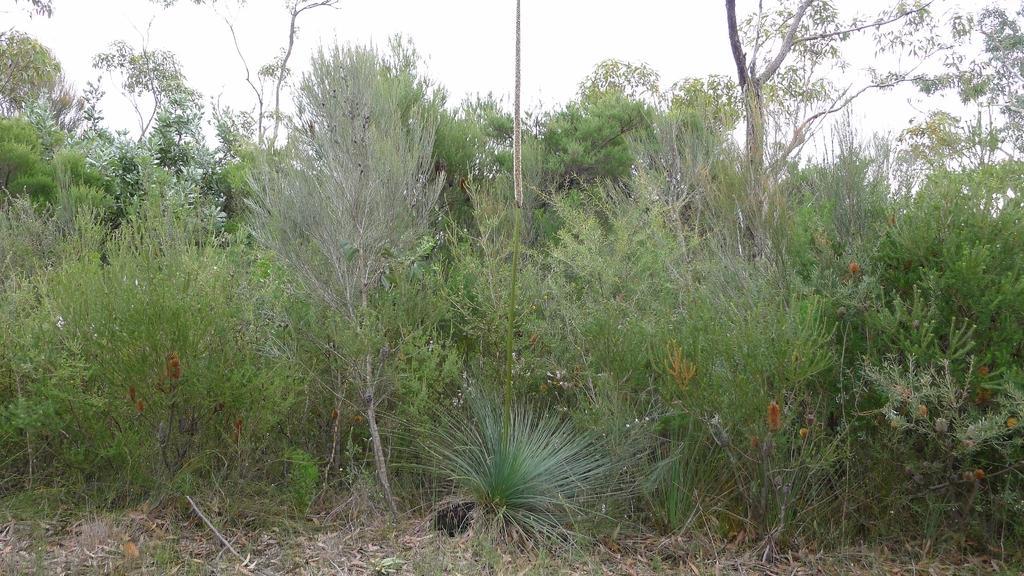Can you describe this image briefly? In this image, I can see plants and trees with branches and leaves. These look like dried leaves lying on the ground. 